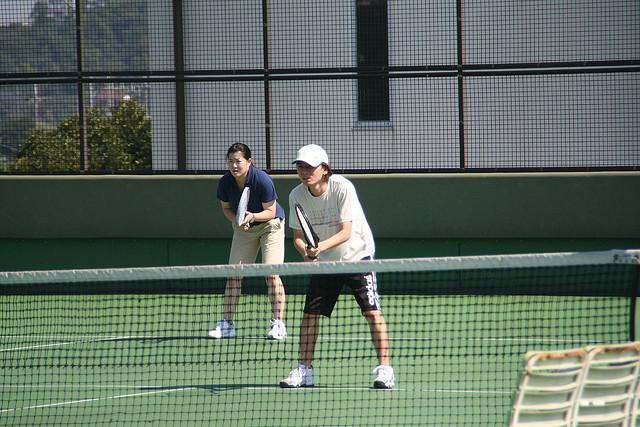Are the people ready for the ball?
Quick response, please. Yes. Are they dressed identical?
Keep it brief. No. Do they look like champions?
Keep it brief. No. What sport are they playing?
Write a very short answer. Tennis. Is the weather warm?
Give a very brief answer. Yes. 